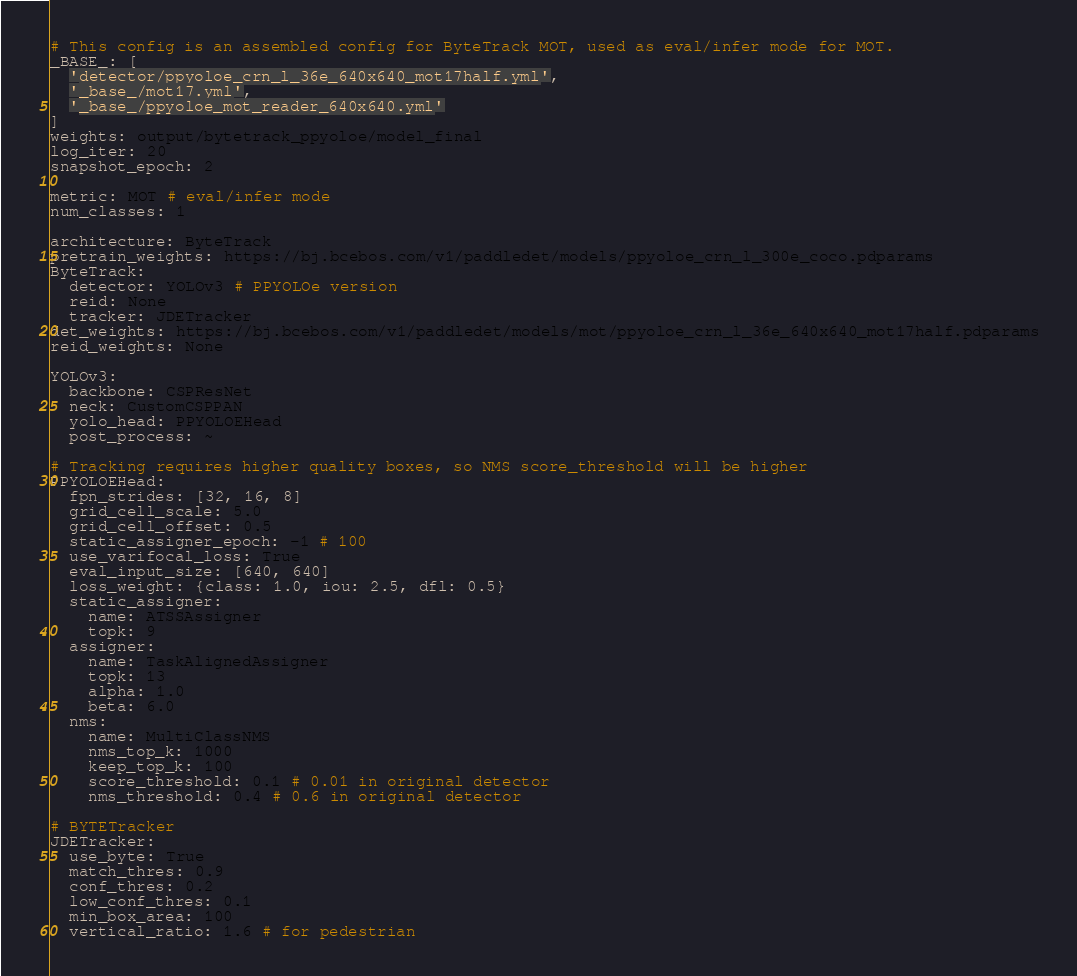Convert code to text. <code><loc_0><loc_0><loc_500><loc_500><_YAML_># This config is an assembled config for ByteTrack MOT, used as eval/infer mode for MOT.
_BASE_: [
  'detector/ppyoloe_crn_l_36e_640x640_mot17half.yml',
  '_base_/mot17.yml',
  '_base_/ppyoloe_mot_reader_640x640.yml'
]
weights: output/bytetrack_ppyoloe/model_final
log_iter: 20
snapshot_epoch: 2

metric: MOT # eval/infer mode
num_classes: 1

architecture: ByteTrack
pretrain_weights: https://bj.bcebos.com/v1/paddledet/models/ppyoloe_crn_l_300e_coco.pdparams
ByteTrack:
  detector: YOLOv3 # PPYOLOe version
  reid: None
  tracker: JDETracker
det_weights: https://bj.bcebos.com/v1/paddledet/models/mot/ppyoloe_crn_l_36e_640x640_mot17half.pdparams
reid_weights: None

YOLOv3:
  backbone: CSPResNet
  neck: CustomCSPPAN
  yolo_head: PPYOLOEHead
  post_process: ~

# Tracking requires higher quality boxes, so NMS score_threshold will be higher
PPYOLOEHead:
  fpn_strides: [32, 16, 8]
  grid_cell_scale: 5.0
  grid_cell_offset: 0.5
  static_assigner_epoch: -1 # 100
  use_varifocal_loss: True
  eval_input_size: [640, 640]
  loss_weight: {class: 1.0, iou: 2.5, dfl: 0.5}
  static_assigner:
    name: ATSSAssigner
    topk: 9
  assigner:
    name: TaskAlignedAssigner
    topk: 13
    alpha: 1.0
    beta: 6.0
  nms:
    name: MultiClassNMS
    nms_top_k: 1000
    keep_top_k: 100
    score_threshold: 0.1 # 0.01 in original detector
    nms_threshold: 0.4 # 0.6 in original detector

# BYTETracker
JDETracker:
  use_byte: True
  match_thres: 0.9
  conf_thres: 0.2
  low_conf_thres: 0.1
  min_box_area: 100
  vertical_ratio: 1.6 # for pedestrian
</code> 